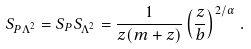Convert formula to latex. <formula><loc_0><loc_0><loc_500><loc_500>S _ { P \Lambda ^ { 2 } } = S _ { P } S _ { \Lambda ^ { 2 } } = \frac { 1 } { z ( m + z ) } \left ( \frac { z } { b } \right ) ^ { 2 / \alpha } \, .</formula> 